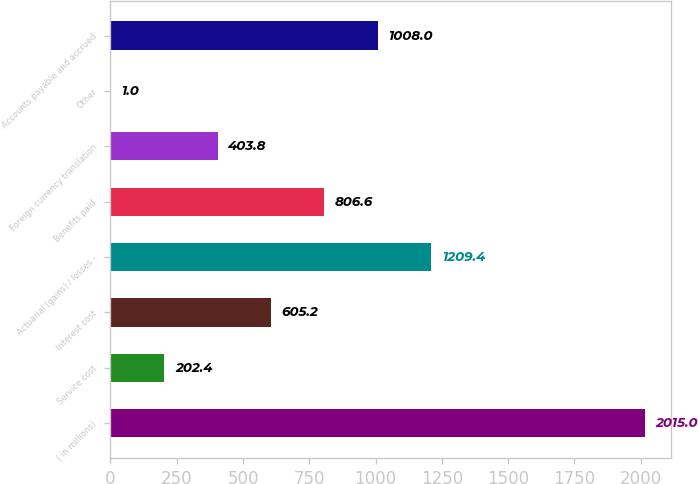Convert chart. <chart><loc_0><loc_0><loc_500><loc_500><bar_chart><fcel>( in millions)<fcel>Service cost<fcel>Interest cost<fcel>Actuarial (gains) / losses -<fcel>Benefits paid<fcel>Foreign currency translation<fcel>Other<fcel>Accounts payable and accrued<nl><fcel>2015<fcel>202.4<fcel>605.2<fcel>1209.4<fcel>806.6<fcel>403.8<fcel>1<fcel>1008<nl></chart> 